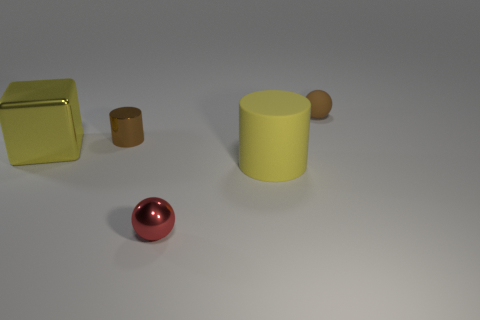What number of other objects are there of the same shape as the tiny red metallic object?
Provide a succinct answer. 1. What is the shape of the object that is both on the right side of the red metallic sphere and in front of the big yellow metal block?
Offer a very short reply. Cylinder. There is a matte object that is left of the ball right of the ball that is in front of the brown cylinder; what color is it?
Your answer should be compact. Yellow. Is the number of tiny metallic things that are behind the large yellow cube greater than the number of red balls right of the red thing?
Offer a terse response. Yes. How many other things are the same size as the metallic cube?
Ensure brevity in your answer.  1. There is a metallic cylinder that is the same color as the tiny matte thing; what size is it?
Make the answer very short. Small. There is a ball that is in front of the yellow thing to the left of the small brown metallic cylinder; what is its material?
Keep it short and to the point. Metal. There is a brown sphere; are there any small balls left of it?
Your answer should be compact. Yes. Is the number of metal cylinders that are behind the big yellow cylinder greater than the number of yellow matte spheres?
Your answer should be compact. Yes. Are there any matte objects that have the same color as the block?
Provide a short and direct response. Yes. 